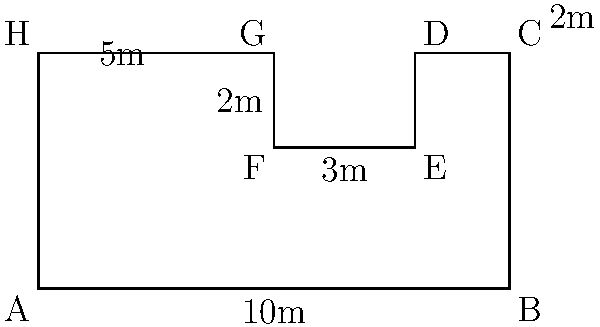You're planning to open a high-end retail store in a prime location. The available space has an irregular floor plan as shown in the diagram. Calculate the total floor area of the store in square meters. How much would it cost to install luxury marble flooring at $250 per square meter? Let's approach this step-by-step:

1) We can divide the floor plan into three rectangles:
   - Rectangle 1: ABCH (main area)
   - Rectangle 2: DEFG (cut-out area)
   - Rectangle 3: CDEG (additional area)

2) Calculate the areas:
   - Area of Rectangle 1 (ABCH): $10m \times 5m = 50m^2$
   - Area of Rectangle 2 (DEFG): $3m \times 2m = 6m^2$
   - Area of Rectangle 3 (CDEG): $2m \times 2m = 4m^2$

3) The total area is:
   $\text{Total Area} = \text{Area}_1 - \text{Area}_2 + \text{Area}_3$
   $= 50m^2 - 6m^2 + 4m^2 = 48m^2$

4) To calculate the cost of flooring:
   $\text{Cost} = \text{Area} \times \text{Price per square meter}$
   $= 48m^2 \times $250/m^2 = $12,000$

Therefore, the total floor area is 48 square meters, and the cost of installing luxury marble flooring would be $12,000.
Answer: 48m², $12,000 